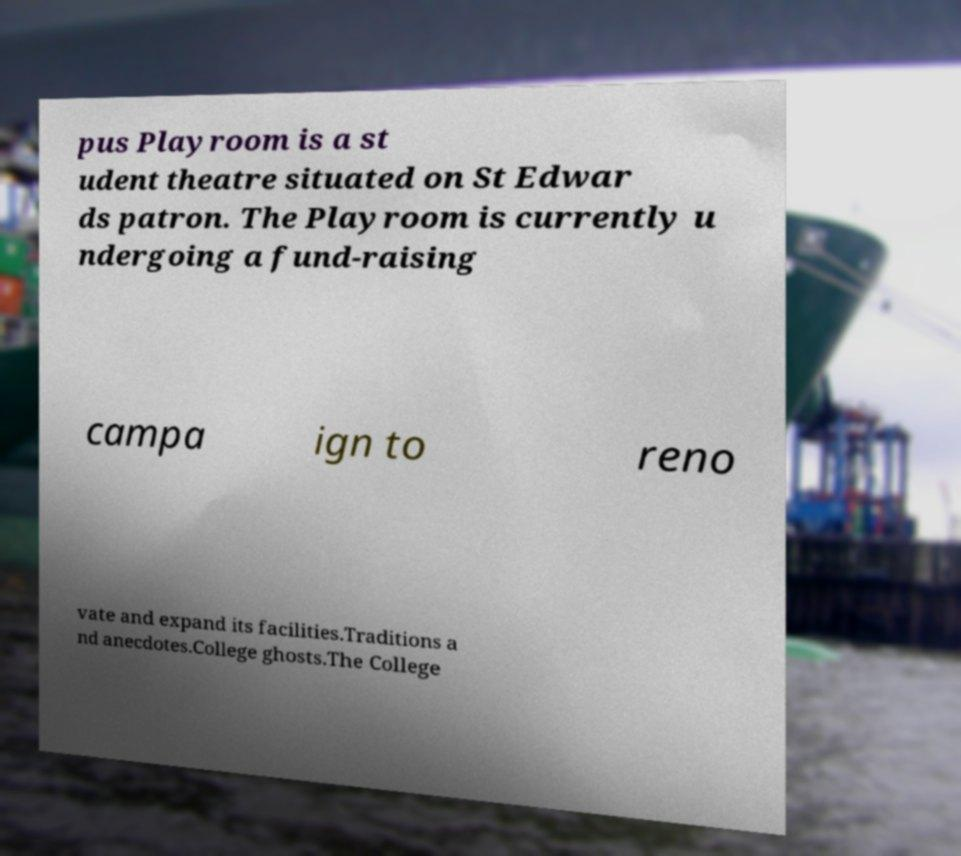For documentation purposes, I need the text within this image transcribed. Could you provide that? pus Playroom is a st udent theatre situated on St Edwar ds patron. The Playroom is currently u ndergoing a fund-raising campa ign to reno vate and expand its facilities.Traditions a nd anecdotes.College ghosts.The College 